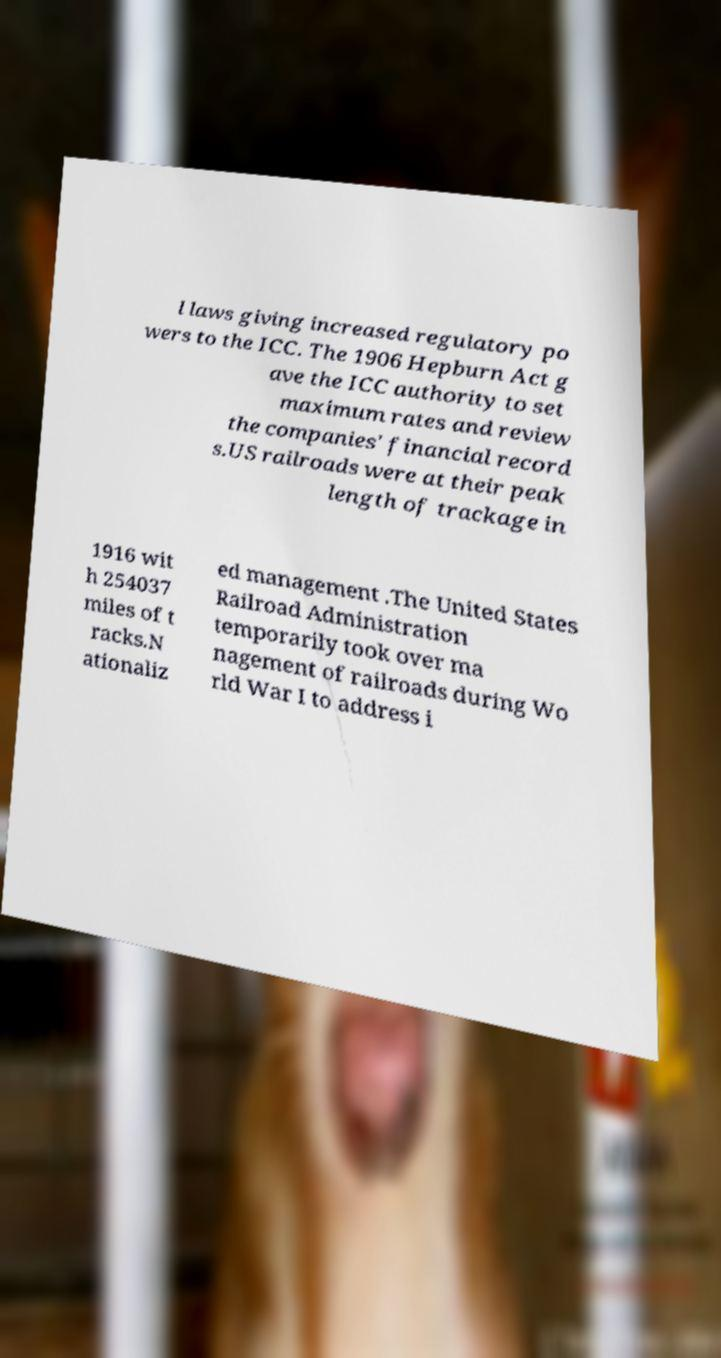Can you accurately transcribe the text from the provided image for me? l laws giving increased regulatory po wers to the ICC. The 1906 Hepburn Act g ave the ICC authority to set maximum rates and review the companies' financial record s.US railroads were at their peak length of trackage in 1916 wit h 254037 miles of t racks.N ationaliz ed management .The United States Railroad Administration temporarily took over ma nagement of railroads during Wo rld War I to address i 